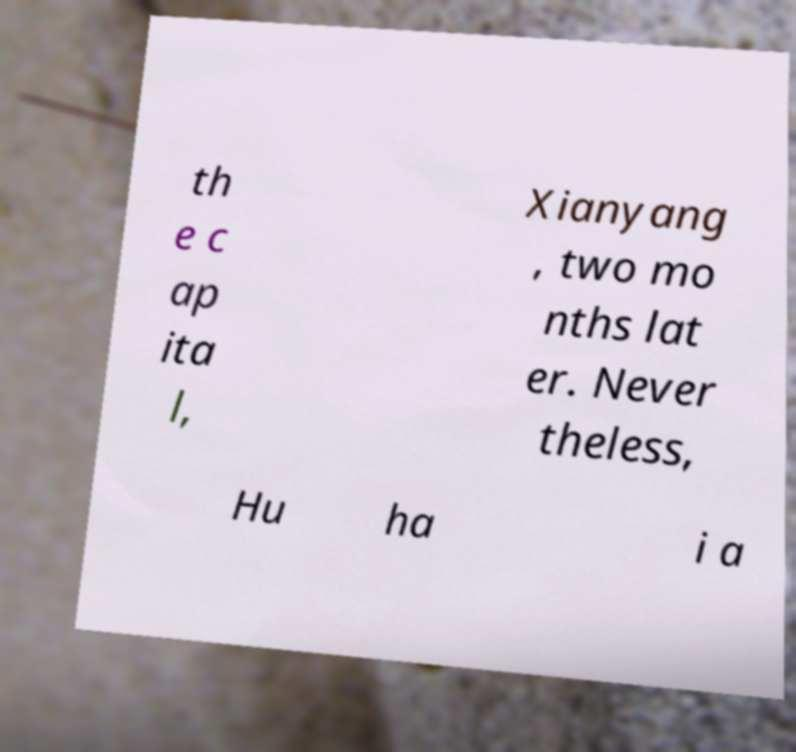Please read and relay the text visible in this image. What does it say? th e c ap ita l, Xianyang , two mo nths lat er. Never theless, Hu ha i a 